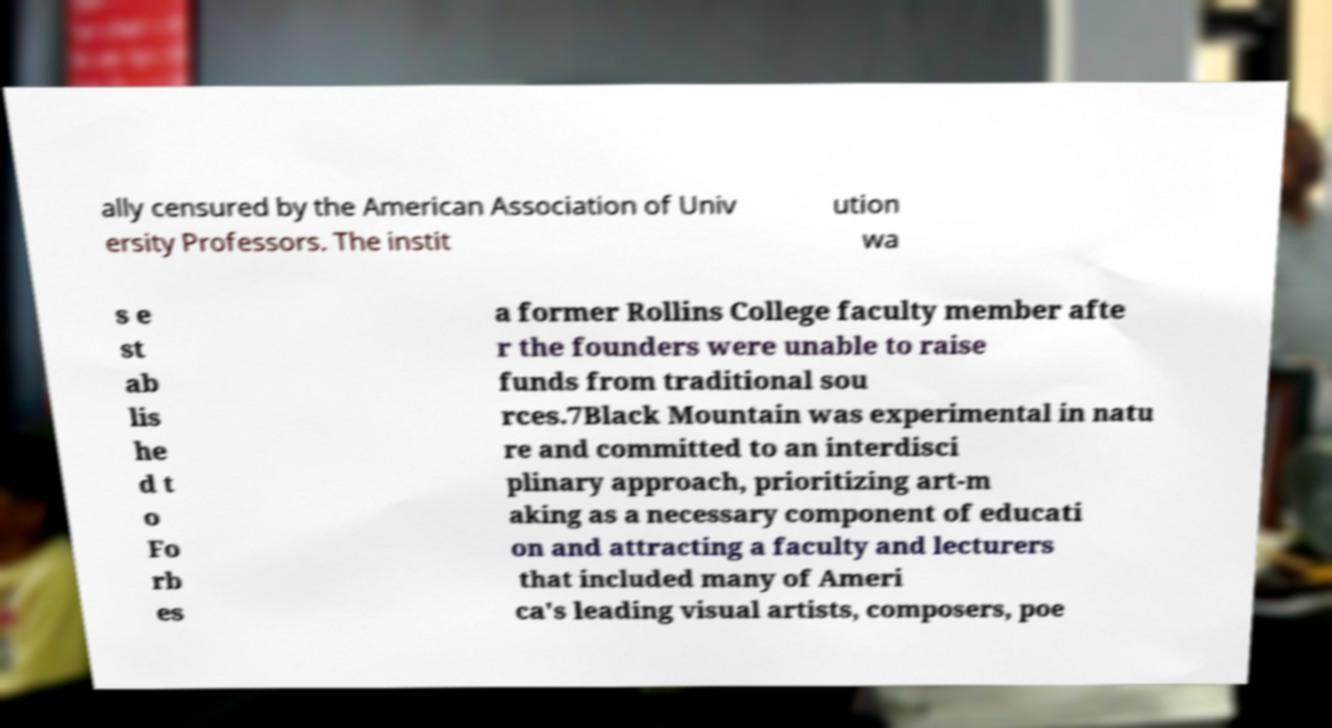Please read and relay the text visible in this image. What does it say? ally censured by the American Association of Univ ersity Professors. The instit ution wa s e st ab lis he d t o Fo rb es a former Rollins College faculty member afte r the founders were unable to raise funds from traditional sou rces.7Black Mountain was experimental in natu re and committed to an interdisci plinary approach, prioritizing art-m aking as a necessary component of educati on and attracting a faculty and lecturers that included many of Ameri ca's leading visual artists, composers, poe 